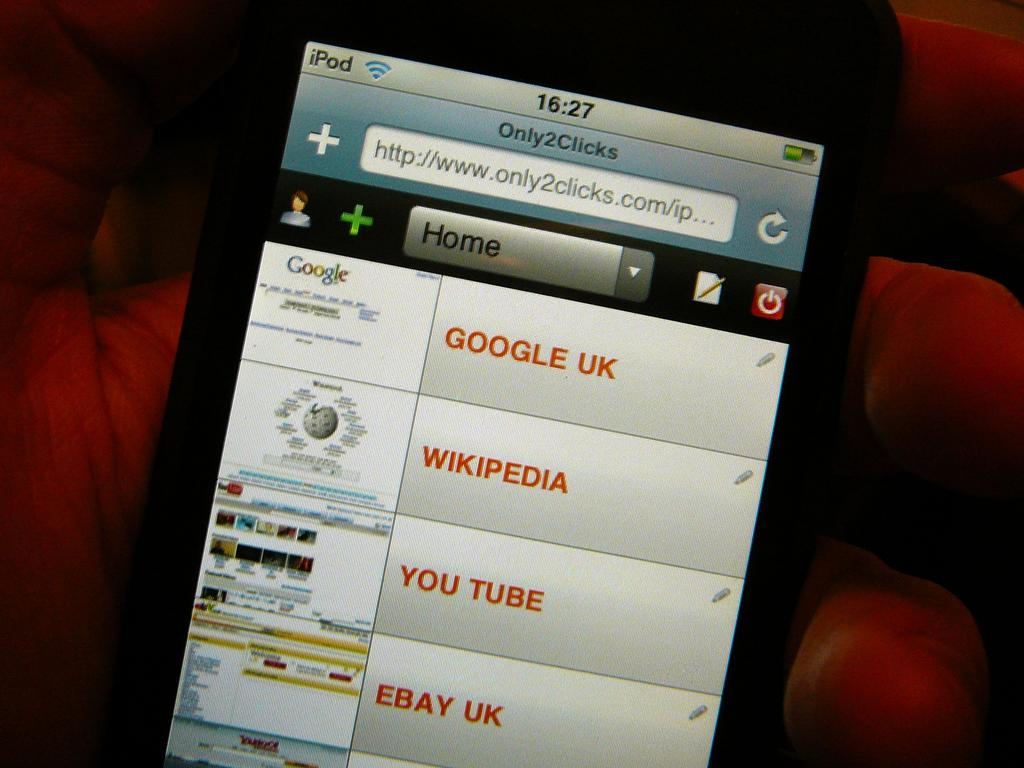<image>
Write a terse but informative summary of the picture. A smart phone with the website only2clicks pulled up on its screen. 